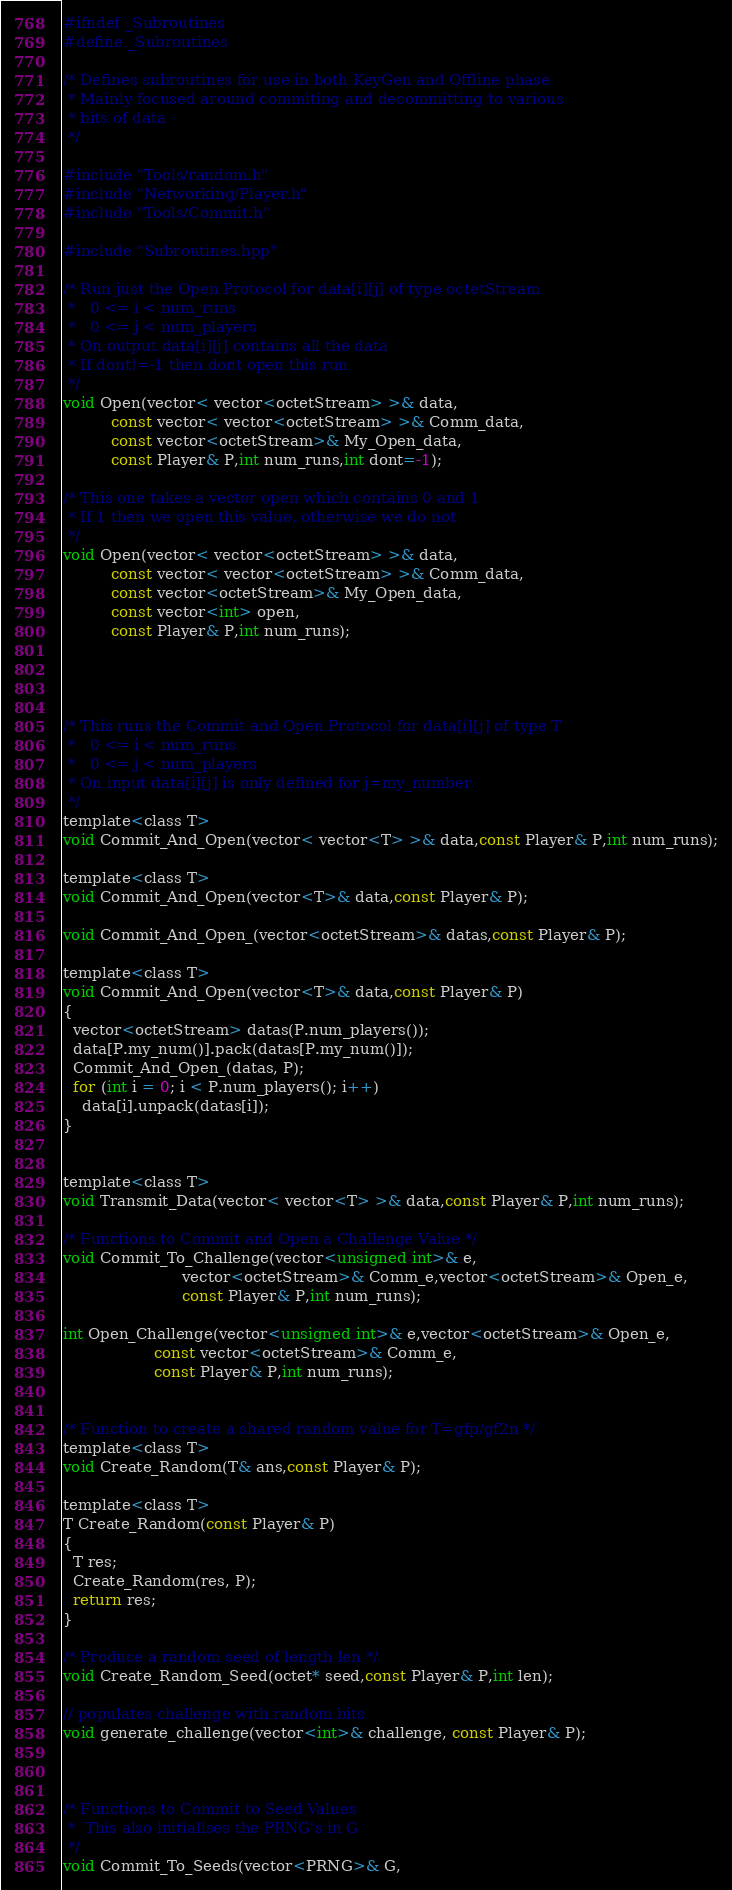<code> <loc_0><loc_0><loc_500><loc_500><_C_>#ifndef _Subroutines
#define _Subroutines

/* Defines subroutines for use in both KeyGen and Offline phase
 * Mainly focused around commiting and decommitting to various
 * bits of data
 */

#include "Tools/random.h"
#include "Networking/Player.h"
#include "Tools/Commit.h"

#include "Subroutines.hpp"

/* Run just the Open Protocol for data[i][j] of type octetStream
 *   0 <= i < num_runs
 *   0 <= j < num_players
 * On output data[i][j] contains all the data
 * If dont!=-1 then dont open this run
 */
void Open(vector< vector<octetStream> >& data,
          const vector< vector<octetStream> >& Comm_data,
          const vector<octetStream>& My_Open_data,
          const Player& P,int num_runs,int dont=-1);

/* This one takes a vector open which contains 0 and 1
 * If 1 then we open this value, otherwise we do not
 */
void Open(vector< vector<octetStream> >& data,
          const vector< vector<octetStream> >& Comm_data,
          const vector<octetStream>& My_Open_data,
          const vector<int> open,
          const Player& P,int num_runs);




/* This runs the Commit and Open Protocol for data[i][j] of type T
 *   0 <= i < num_runs
 *   0 <= j < num_players
 * On input data[i][j] is only defined for j=my_number
 */
template<class T>
void Commit_And_Open(vector< vector<T> >& data,const Player& P,int num_runs);

template<class T>
void Commit_And_Open(vector<T>& data,const Player& P);

void Commit_And_Open_(vector<octetStream>& datas,const Player& P);

template<class T>
void Commit_And_Open(vector<T>& data,const Player& P)
{
  vector<octetStream> datas(P.num_players());
  data[P.my_num()].pack(datas[P.my_num()]);
  Commit_And_Open_(datas, P);
  for (int i = 0; i < P.num_players(); i++)
    data[i].unpack(datas[i]);
}


template<class T>
void Transmit_Data(vector< vector<T> >& data,const Player& P,int num_runs);

/* Functions to Commit and Open a Challenge Value */
void Commit_To_Challenge(vector<unsigned int>& e,
                         vector<octetStream>& Comm_e,vector<octetStream>& Open_e,
                         const Player& P,int num_runs);

int Open_Challenge(vector<unsigned int>& e,vector<octetStream>& Open_e,
                   const vector<octetStream>& Comm_e,
                   const Player& P,int num_runs);


/* Function to create a shared random value for T=gfp/gf2n */
template<class T>
void Create_Random(T& ans,const Player& P);

template<class T>
T Create_Random(const Player& P)
{
  T res;
  Create_Random(res, P);
  return res;
}

/* Produce a random seed of length len */
void Create_Random_Seed(octet* seed,const Player& P,int len);

// populates challenge with random bits
void generate_challenge(vector<int>& challenge, const Player& P);



/* Functions to Commit to Seed Values 
 *  This also initialises the PRNG's in G
 */
void Commit_To_Seeds(vector<PRNG>& G,</code> 